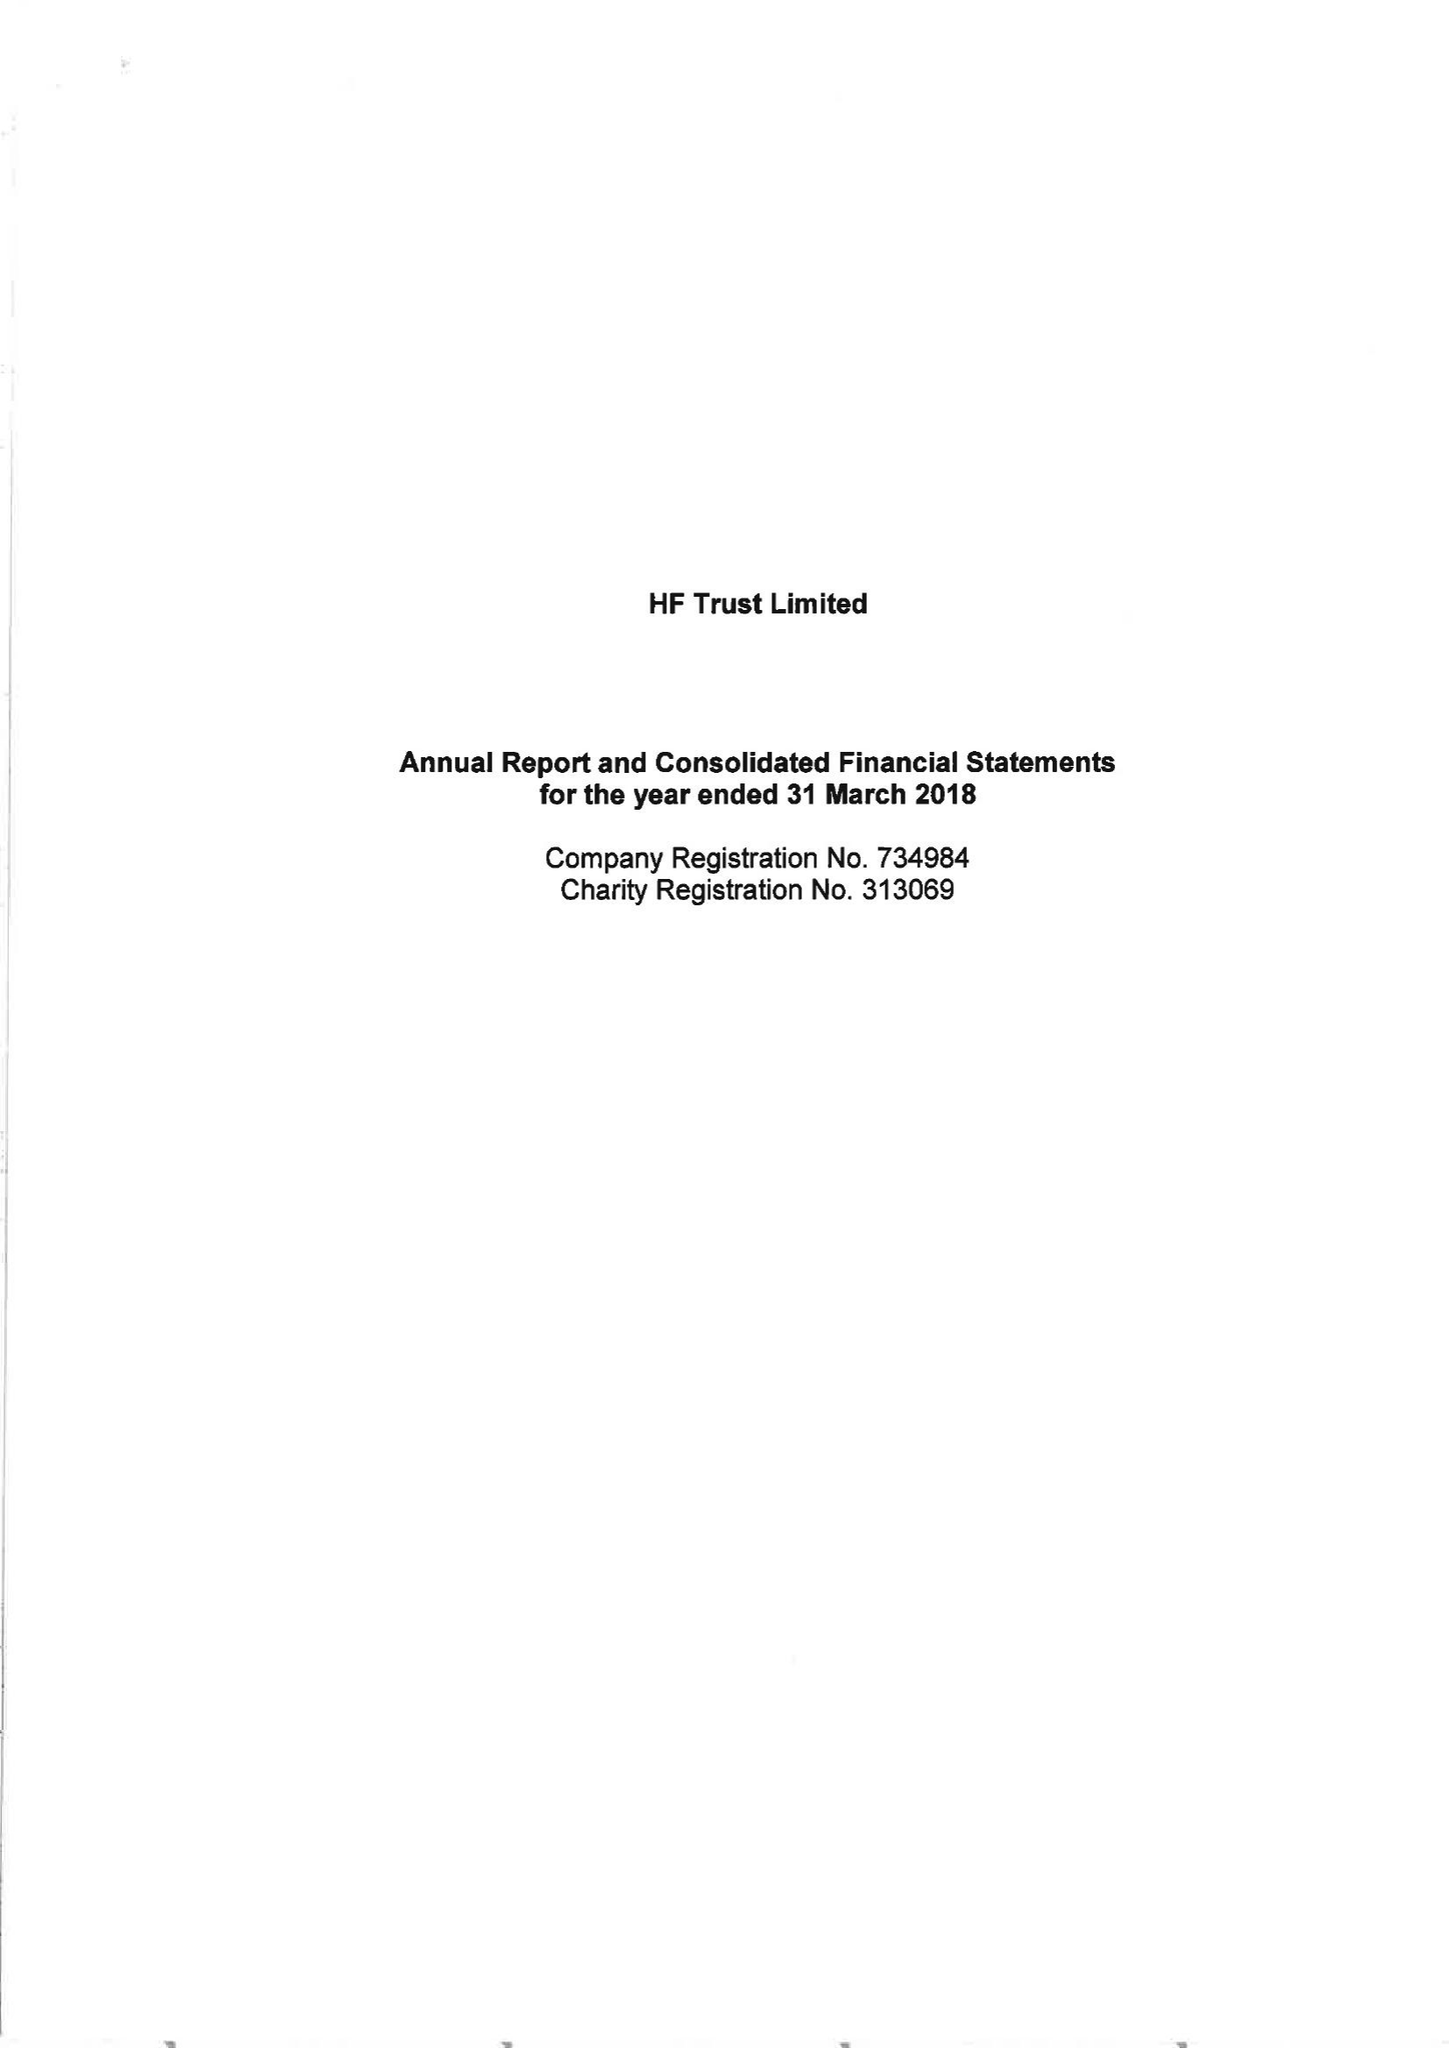What is the value for the address__street_line?
Answer the question using a single word or phrase. None 